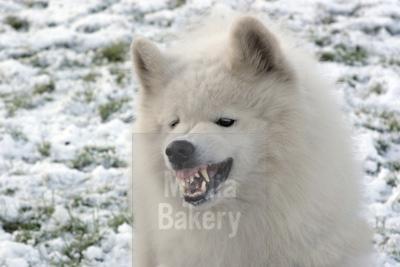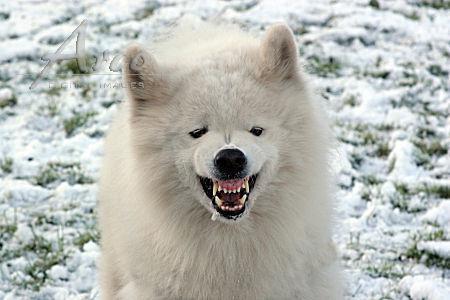The first image is the image on the left, the second image is the image on the right. Examine the images to the left and right. Is the description "An image shows an open-mouthed white dog with tongue showing and a non-fierce expression." accurate? Answer yes or no. No. The first image is the image on the left, the second image is the image on the right. Assess this claim about the two images: "There's at least one angry dog showing its teeth in the image pair.". Correct or not? Answer yes or no. Yes. 